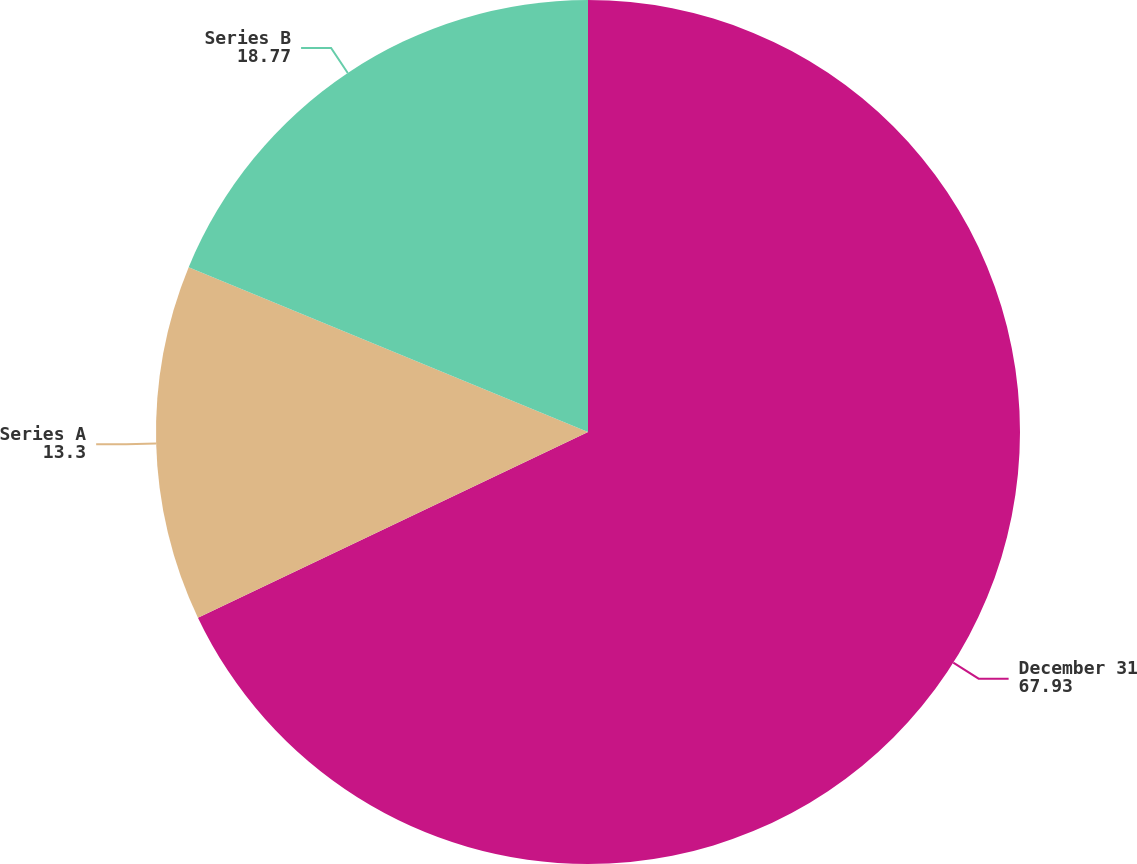Convert chart to OTSL. <chart><loc_0><loc_0><loc_500><loc_500><pie_chart><fcel>December 31<fcel>Series A<fcel>Series B<nl><fcel>67.93%<fcel>13.3%<fcel>18.77%<nl></chart> 